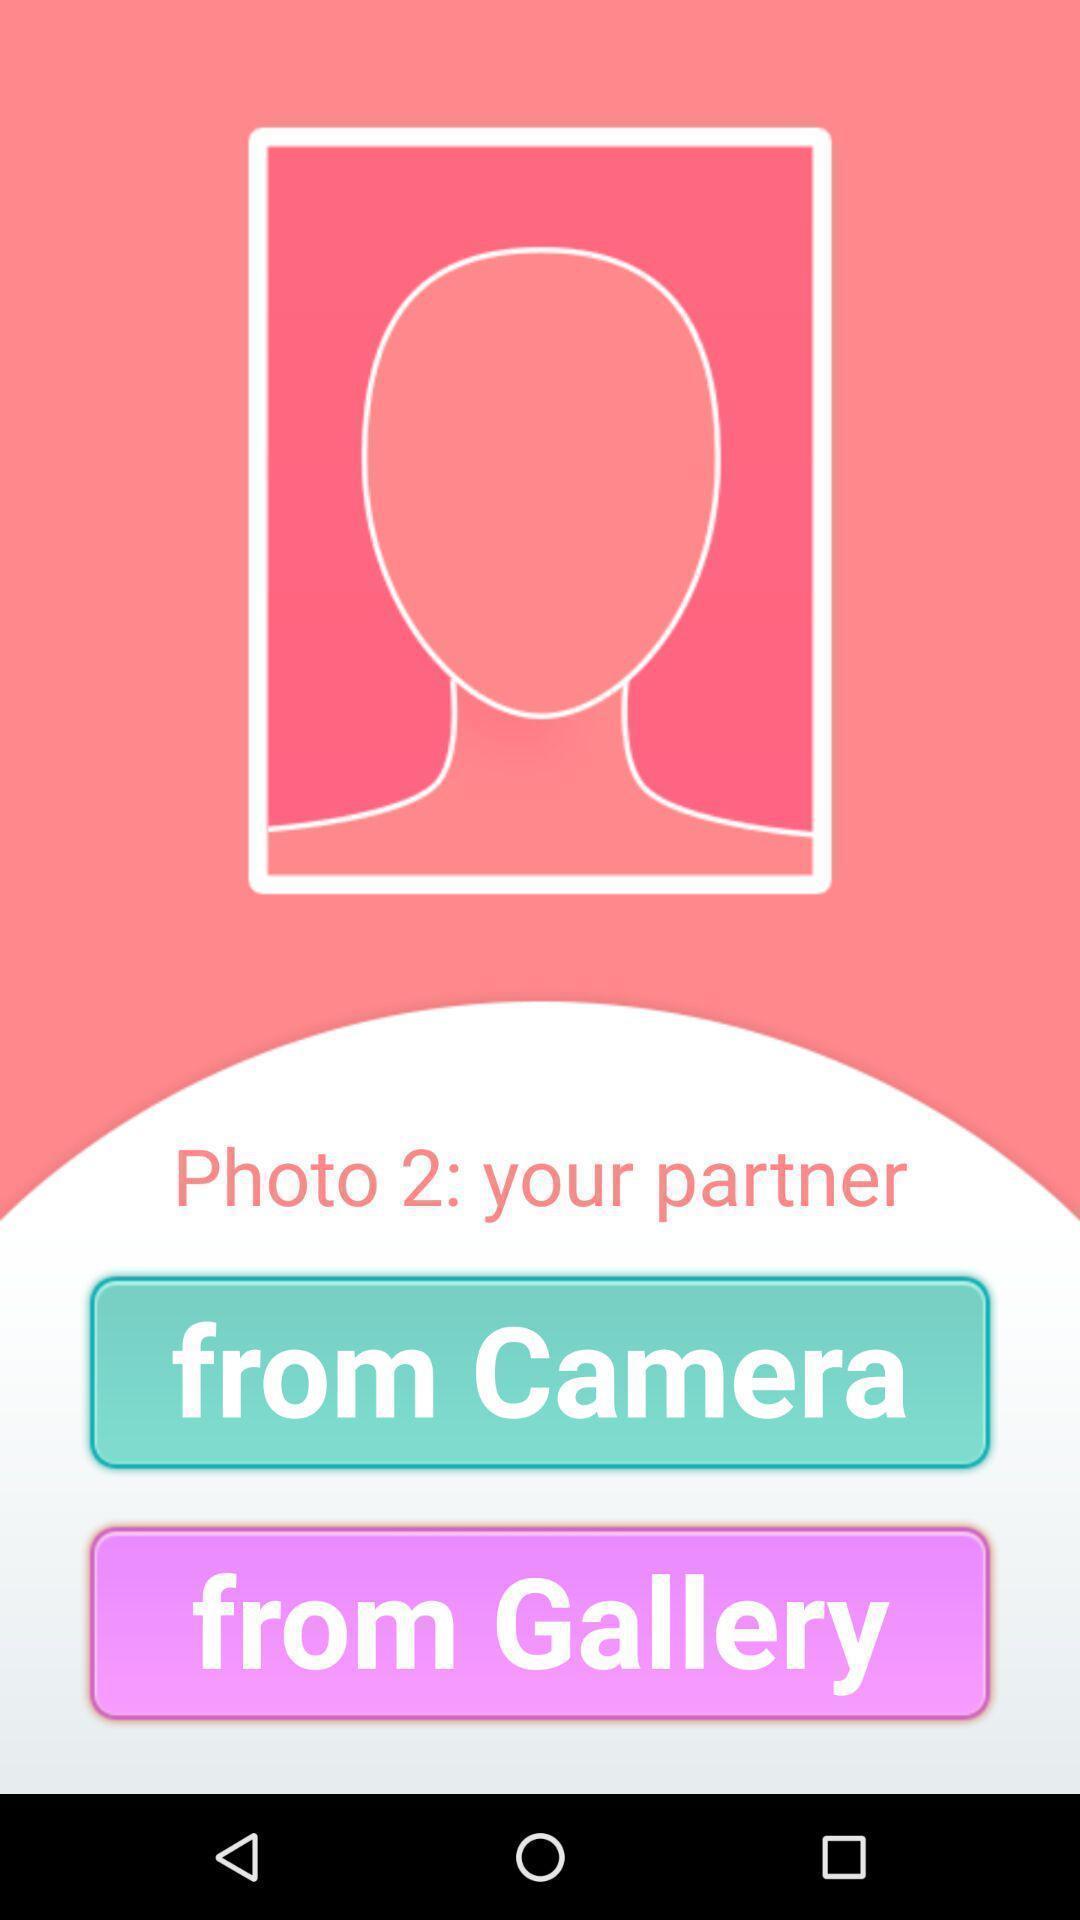Describe the key features of this screenshot. Page with options to upload photo. 